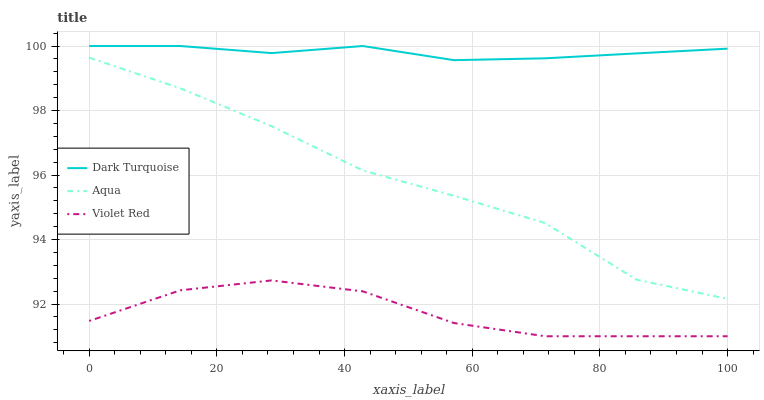Does Violet Red have the minimum area under the curve?
Answer yes or no. Yes. Does Dark Turquoise have the maximum area under the curve?
Answer yes or no. Yes. Does Aqua have the minimum area under the curve?
Answer yes or no. No. Does Aqua have the maximum area under the curve?
Answer yes or no. No. Is Dark Turquoise the smoothest?
Answer yes or no. Yes. Is Aqua the roughest?
Answer yes or no. Yes. Is Violet Red the smoothest?
Answer yes or no. No. Is Violet Red the roughest?
Answer yes or no. No. Does Aqua have the lowest value?
Answer yes or no. No. Does Dark Turquoise have the highest value?
Answer yes or no. Yes. Does Aqua have the highest value?
Answer yes or no. No. Is Aqua less than Dark Turquoise?
Answer yes or no. Yes. Is Dark Turquoise greater than Aqua?
Answer yes or no. Yes. Does Aqua intersect Dark Turquoise?
Answer yes or no. No. 